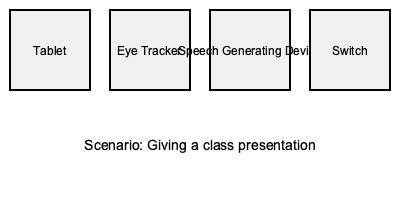Which assistive technology device would be most appropriate for giving a class presentation? To determine the most appropriate assistive technology for giving a class presentation, let's consider each option:

1. Tablet: While tablets can be useful for communication, they may not be ideal for presenting to a large group.

2. Eye Tracker: This device is typically used for cursor control and selection, which is not the primary need for a presentation.

3. Speech Generating Device: This is the most suitable option for a class presentation because:
   a) It can produce clear, audible speech for the entire class to hear.
   b) It allows for pre-programmed phrases or sentences, which is useful for prepared presentations.
   c) It enables real-time communication for answering questions or elaborating on points.

4. Switch: A switch is usually used to activate other devices or make selections, which is not sufficient for delivering a full presentation.

Given the scenario of giving a class presentation, the Speech Generating Device offers the best combination of features for clear communication to a group.
Answer: Speech Generating Device 